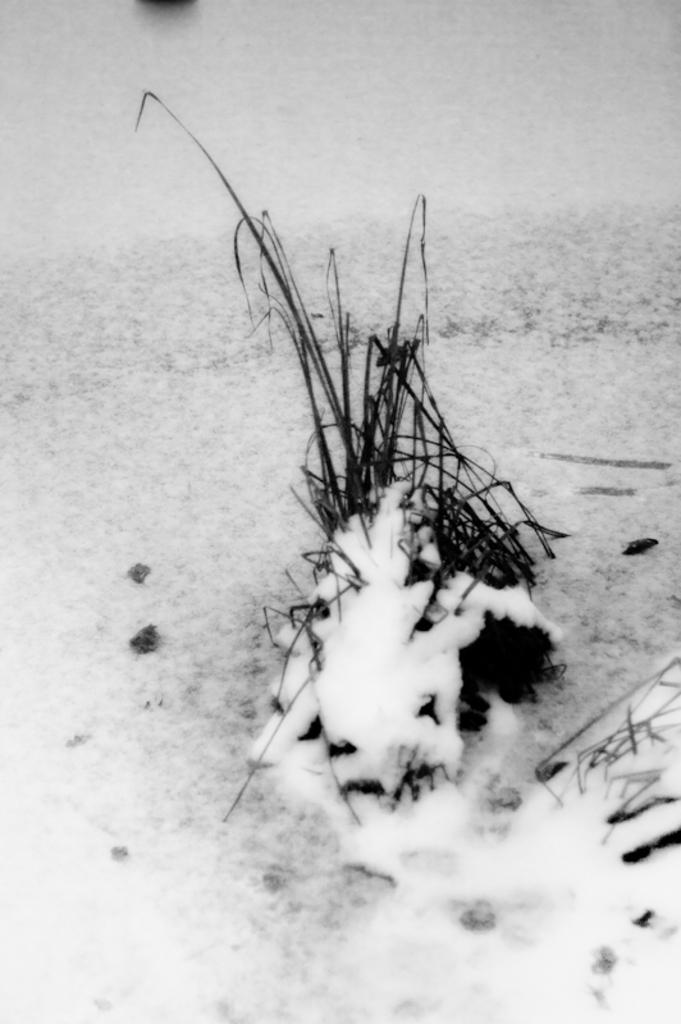What is the main subject of the conversation? The main subject of the conversation is the absurd topics: cook, furniture, and answer. Can you describe a scenario involving a cook? A cook might be preparing a meal in a kitchen, using various utensils and ingredients. What role does furniture play in a typical living space? Furniture provides comfort and functionality, allowing people to sit, sleep, eat, and store items in a room. How might someone provide an answer to a question? Someone might provide an answer by sharing their knowledge, experience, or opinion on a particular topic or question. Reasoning: Since there are no facts about an image to guide the conversation, we have created a conversation based on the provided absurd topics. We have discussed each topic individually, providing examples and explanations to help illustrate their meanings. This approach allows us to create a conversation without relying on specific details about an image. Absurd Question/Answer: What type of furniture can be seen in the ice cream bowl in the image? There is no furniture present in the ice cream bowl, as it is a bowl containing ice cream and not a living space or area where furniture would be found. 